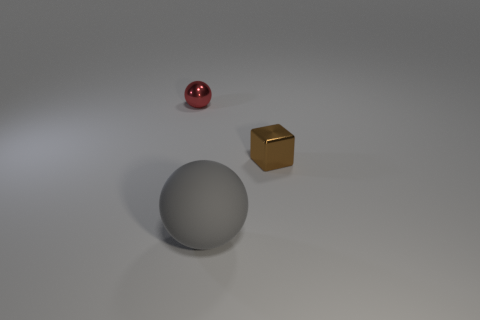Subtract all spheres. How many objects are left? 1 Add 3 matte spheres. How many matte spheres are left? 4 Add 2 large red matte cubes. How many large red matte cubes exist? 2 Add 1 tiny shiny cubes. How many objects exist? 4 Subtract 0 blue blocks. How many objects are left? 3 Subtract 1 balls. How many balls are left? 1 Subtract all green cubes. Subtract all brown cylinders. How many cubes are left? 1 Subtract all purple spheres. How many gray cubes are left? 0 Subtract all tiny brown metallic cubes. Subtract all small brown blocks. How many objects are left? 1 